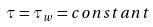<formula> <loc_0><loc_0><loc_500><loc_500>\tau = \tau _ { w } = { c o n s t a n t }</formula> 